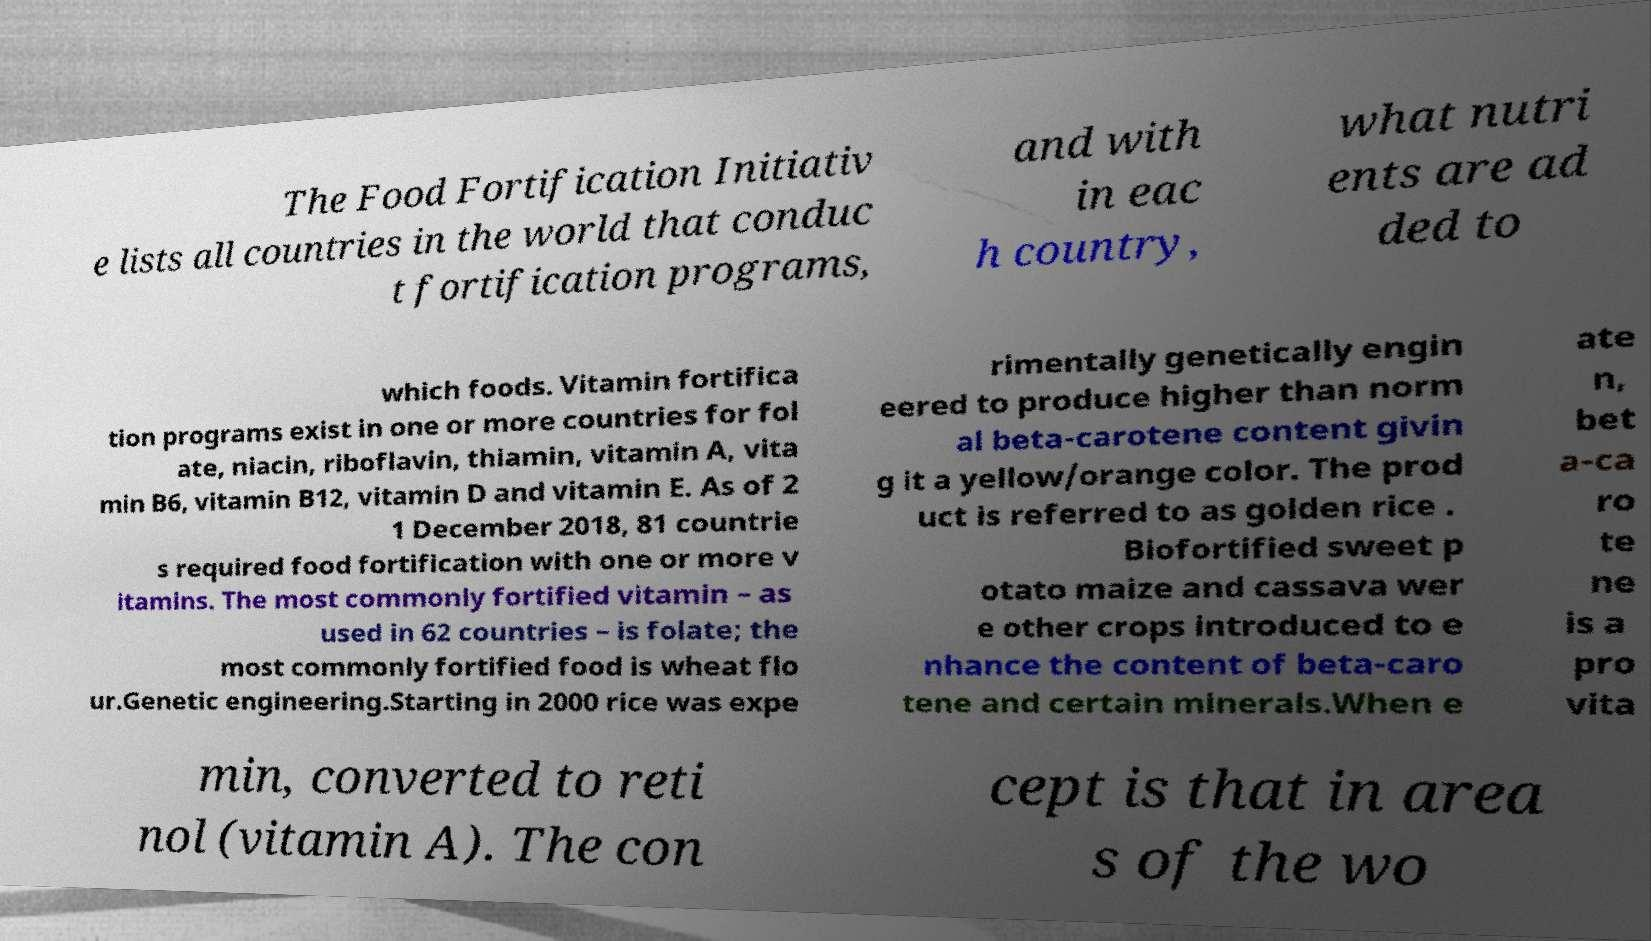For documentation purposes, I need the text within this image transcribed. Could you provide that? The Food Fortification Initiativ e lists all countries in the world that conduc t fortification programs, and with in eac h country, what nutri ents are ad ded to which foods. Vitamin fortifica tion programs exist in one or more countries for fol ate, niacin, riboflavin, thiamin, vitamin A, vita min B6, vitamin B12, vitamin D and vitamin E. As of 2 1 December 2018, 81 countrie s required food fortification with one or more v itamins. The most commonly fortified vitamin – as used in 62 countries – is folate; the most commonly fortified food is wheat flo ur.Genetic engineering.Starting in 2000 rice was expe rimentally genetically engin eered to produce higher than norm al beta-carotene content givin g it a yellow/orange color. The prod uct is referred to as golden rice . Biofortified sweet p otato maize and cassava wer e other crops introduced to e nhance the content of beta-caro tene and certain minerals.When e ate n, bet a-ca ro te ne is a pro vita min, converted to reti nol (vitamin A). The con cept is that in area s of the wo 